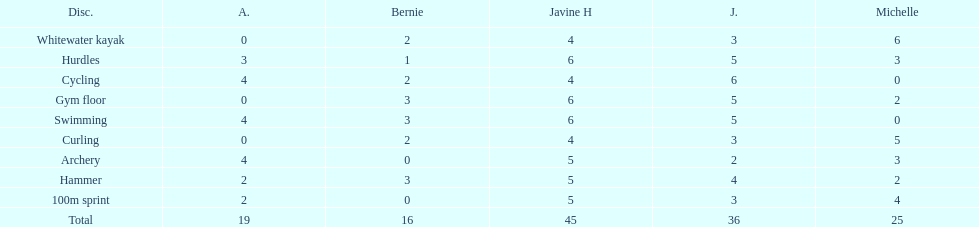What other girl besides amanda also had a 4 in cycling? Javine H. 